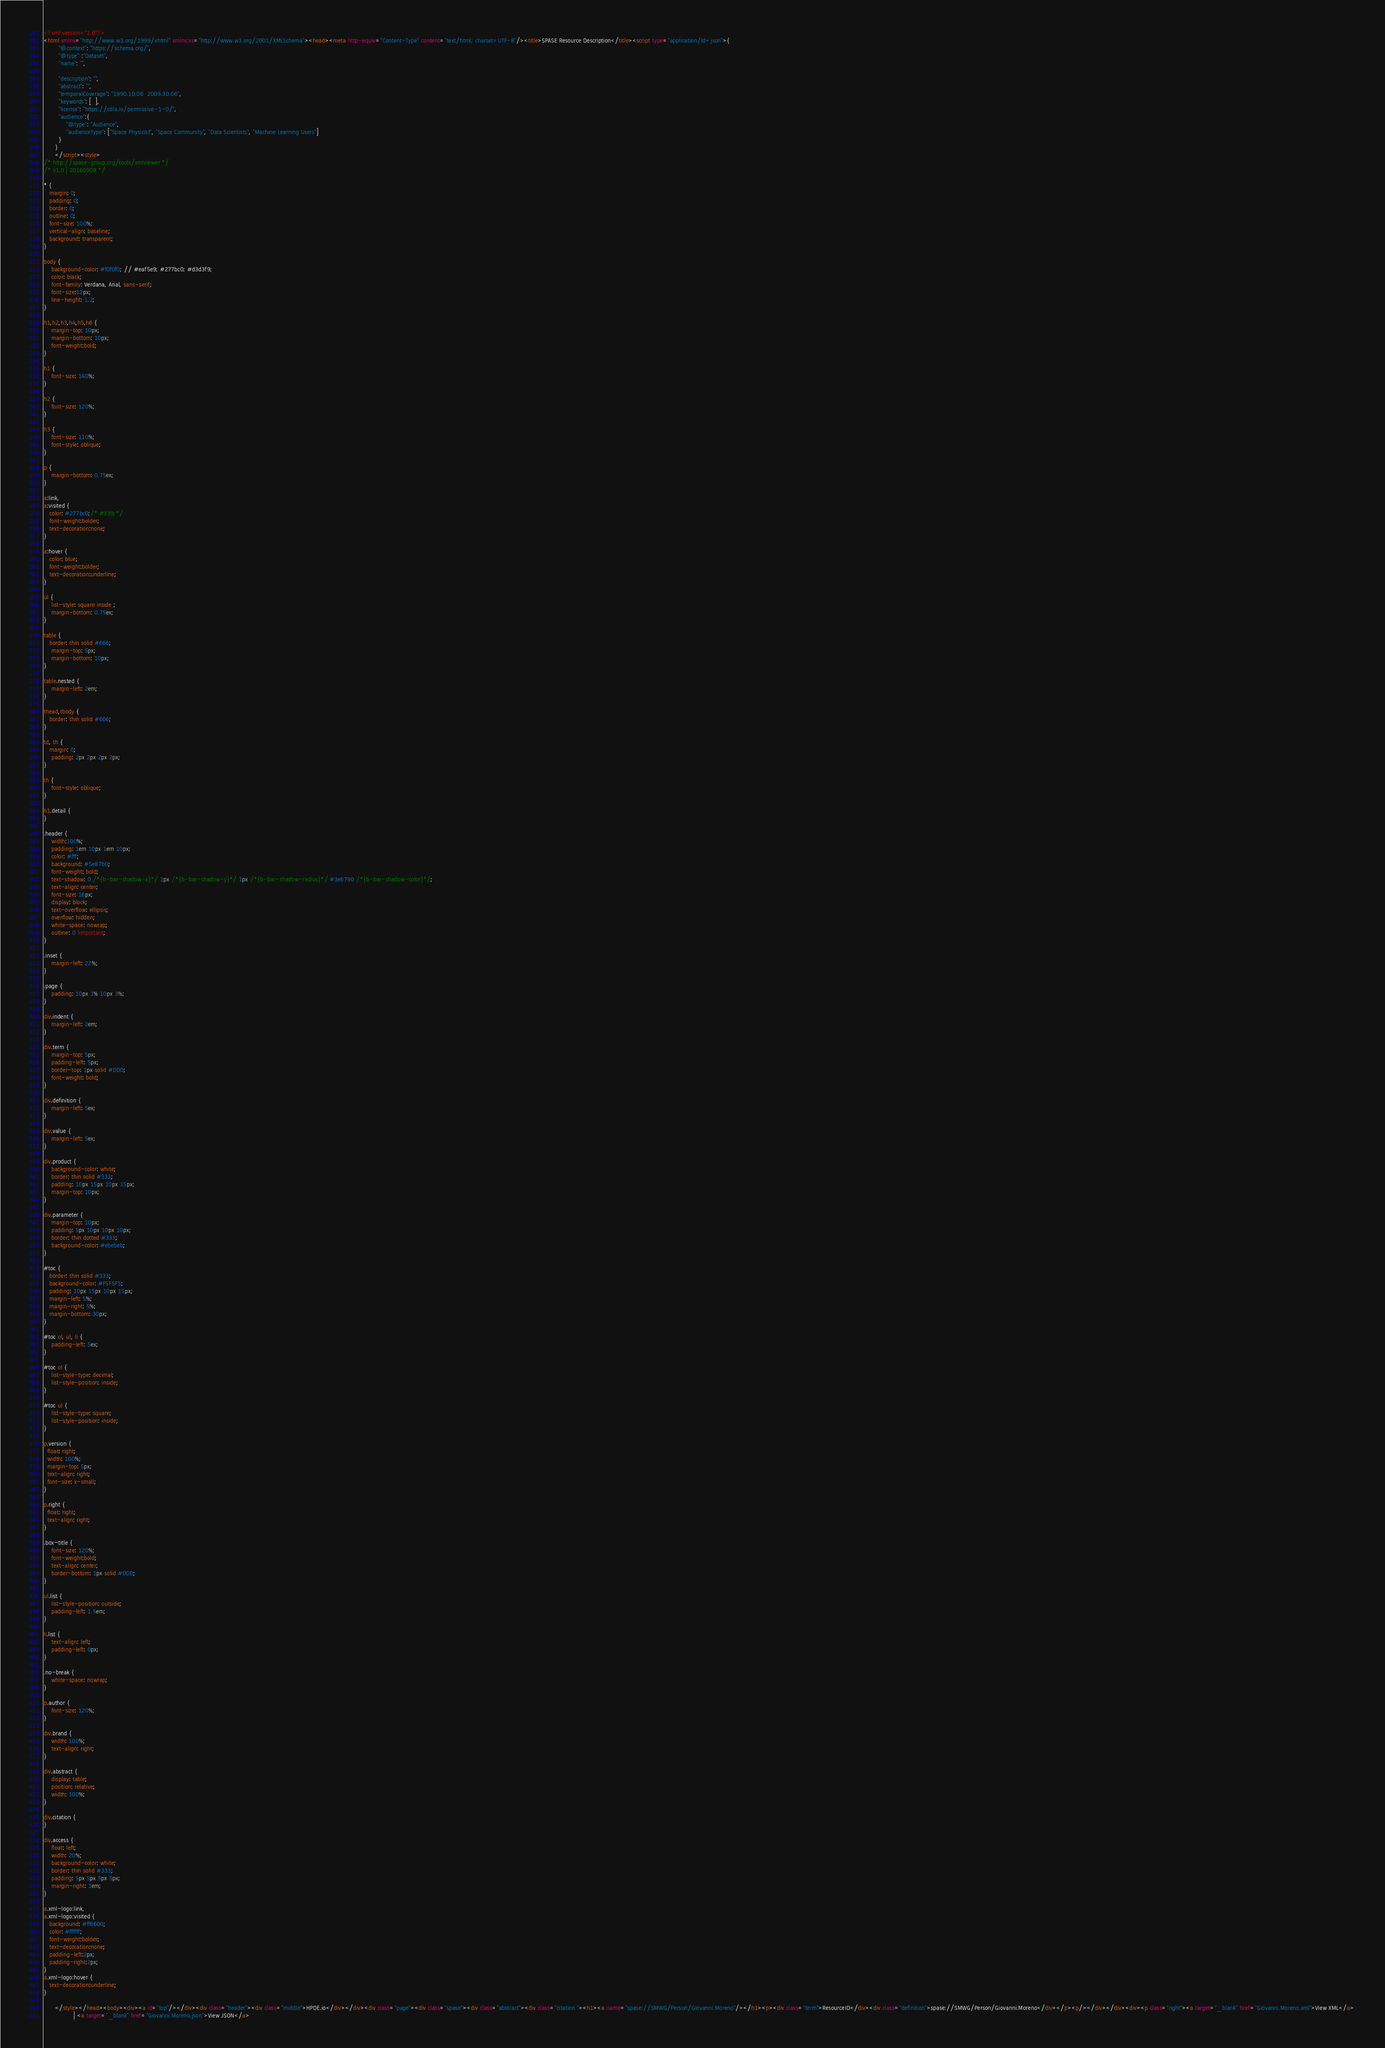<code> <loc_0><loc_0><loc_500><loc_500><_HTML_><?xml version="1.0"?>
<html xmlns="http://www.w3.org/1999/xhtml" xmlns:xs="http://www.w3.org/2001/XMLSchema"><head><meta http-equiv="Content-Type" content="text/html; charset=UTF-8"/><title>SPASE Resource Description</title><script type="application/ld+json">{
		"@context": "https://schema.org/",
		"@type" :"Dataset",
		"name": "",
     
 		"description": "",
		"abstract": "",
		"temporalCoverage": "1990.10.06  2009.30.06",
		"keywords": [  ],
		"license": "https://cdla.io/permissive-1-0/",
        "audience":{
            "@type": "Audience",
            "audienceType": ["Space Physicist", "Space Community", "Data Scientists", "Machine Learning Users"]
        }
	  }
	  </script><style>
/* http://spase-group.org/tools/xmlviewer */
/* v1.0 | 20160908 */

* {
   margin: 0;
   padding: 0;
   border: 0;
   outline: 0;
   font-size: 100%;
   vertical-align: baseline;
   background: transparent;
}

body {
	background-color: #f0f0f0; // #eaf5e9; #277bc0; #d3d3f9;
	color: black;
	font-family: Verdana, Arial, sans-serif; 
	font-size:12px; 
	line-height: 1.2;
}
 
h1,h2,h3,h4,h5,h6 {
	margin-top: 10px;
	margin-bottom: 10px;
	font-weight:bold;
}

h1 {
	font-size: 140%;
}

h2 {
	font-size: 120%;
}

h3 {
	font-size: 110%;
	font-style: oblique;
}

p {
	margin-bottom: 0.75ex;
}

a:link,
a:visited {
   color: #277bc0;/* #339;*/
   font-weight:bolder; 
   text-decoration:none; 
}

a:hover {
   color: blue;
   font-weight:bolder; 
   text-decoration:underline; 
}

ul {
	list-style: square inside ;
	margin-bottom: 0.75ex;
}

table {
   border: thin solid #666;
	margin-top: 5px;
	margin-bottom: 10px;
}

table.nested {
	margin-left: 2em;
}

thead,tbody {
   border: thin solid #666;
}

td, th {
   margin: 0;
	padding: 2px 2px 2px 2px;
}

th {
	font-style: oblique;
}

h1.detail {
}

.header {
	width:100%;
	padding: 1em 10px 1em 10px;
	color: #fff;
	background: #5e87b0;
	font-weight: bold;
	text-shadow: 0 /*{b-bar-shadow-x}*/ 1px /*{b-bar-shadow-y}*/ 1px /*{b-bar-shadow-radius}*/ #3e6790 /*{b-bar-shadow-color}*/;
	text-align: center;
	font-size: 16px;
	display: block;
	text-overflow: ellipsis;
	overflow: hidden;
	white-space: nowrap;
	outline: 0 !important;
}

.inset {
	margin-left: 22%;
}

.page {
	padding: 10px 3% 10px 3%;
}

div.indent {
    margin-left: 2em;
}

div.term {
	margin-top: 5px;
	padding-left: 5px;
	border-top: 1px solid #DDD;
	font-weight: bold;
}

div.definition {
	margin-left: 5ex;
}

div.value {
	margin-left: 5ex;
}

div.product {
	background-color: white;
	border: thin solid #333;
	padding: 10px 15px 10px 15px;
	margin-top: 10px;
}

div.parameter {
	margin-top: 10px;
	padding: 5px 10px 10px 10px;
	border: thin dotted #333;
	background-color: #ebebeb;
}

#toc {
   border: thin solid #333;
   background-color: #F5F5F5; 
   padding: 10px 15px 10px 15px;
   margin-left: 5%;
   margin-right: 5%;
   margin-bottom: 30px;
}

#toc ol, ul, li {
	padding-left: 5ex;
}

#toc ol {
	list-style-type: decimal;
	list-style-position: inside; 
}

#toc ul {
	list-style-type: square;
	list-style-position: inside; 
}

p.version {
  float: right;
  width: 100%;
  margin-top: 5px;
  text-align: right;
  font-size: x-small;
}

p.right {
  float: right;
  text-align: right;
}

.box-title {
	font-size: 120%;
	font-weight:bold;
	text-align: center;
	border-bottom: 1px solid #DDD;
}

ul.list {
	list-style-position: outside;
	padding-left: 1.5em;
}

li.list {
	text-align: left;
	padding-left: 0px;
}

.no-break {
	white-space: nowrap;
}

p.author {
	font-size: 120%;
}

div.brand {
	width: 100%;
	text-align: right;
}

div.abstract {
	display: table;
	position: relative;
	width: 100%;
}

div.citation {
}

div.access {
	float: left;
	width: 20%;
	background-color: white;
	border: thin solid #333;
	padding: 5px 5px 5px 5px;
	margin-right: 1em;
}

a.xml-logo:link,
a.xml-logo:visited {
   background: #ff6600;
   color: #ffffff;
   font-weight:bolder; 
   text-decoration:none; 
   padding-left:2px;
   padding-right:2px;
}
a.xml-logo:hover {
   text-decoration:underline; 
}

	  </style></head><body><div><a id="top"/></div><div class="header"><div class="middle">HPDE.io</div></div><div class="page"><div class="spase"><div class="abstract"><div class="citation "><h1><a name="spase://SMWG/Person/Giovanni.Moreno"/></h1><p><div class="term">ResourceID</div><div class="definition">spase://SMWG/Person/Giovanni.Moreno</div></p><p/></div></div><div><p class="right"><a target="_blank" href="Giovanni.Moreno.xml">View XML</a> 
				| <a target="_blank" href="Giovanni.Moreno.json">View JSON</a> </code> 